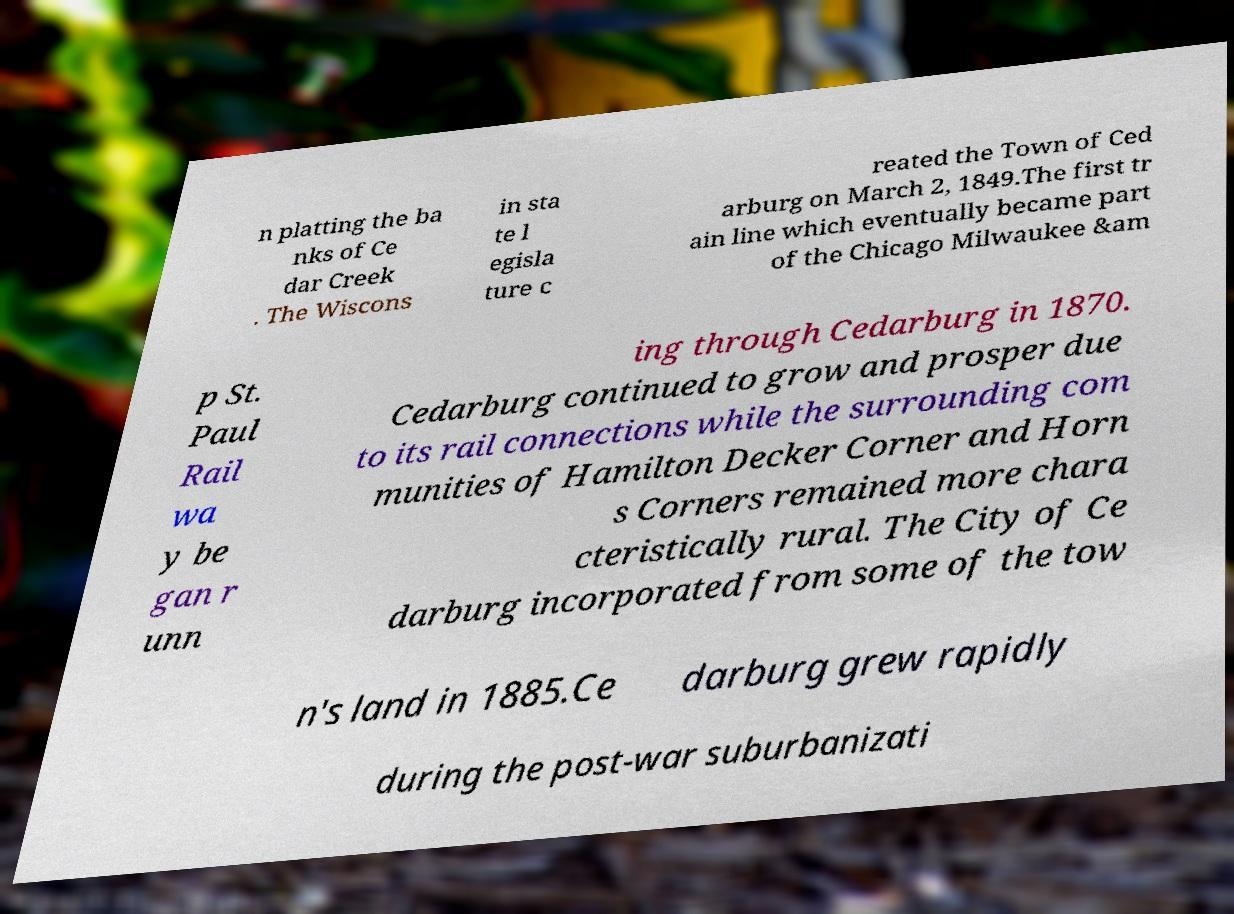For documentation purposes, I need the text within this image transcribed. Could you provide that? n platting the ba nks of Ce dar Creek . The Wiscons in sta te l egisla ture c reated the Town of Ced arburg on March 2, 1849.The first tr ain line which eventually became part of the Chicago Milwaukee &am p St. Paul Rail wa y be gan r unn ing through Cedarburg in 1870. Cedarburg continued to grow and prosper due to its rail connections while the surrounding com munities of Hamilton Decker Corner and Horn s Corners remained more chara cteristically rural. The City of Ce darburg incorporated from some of the tow n's land in 1885.Ce darburg grew rapidly during the post-war suburbanizati 